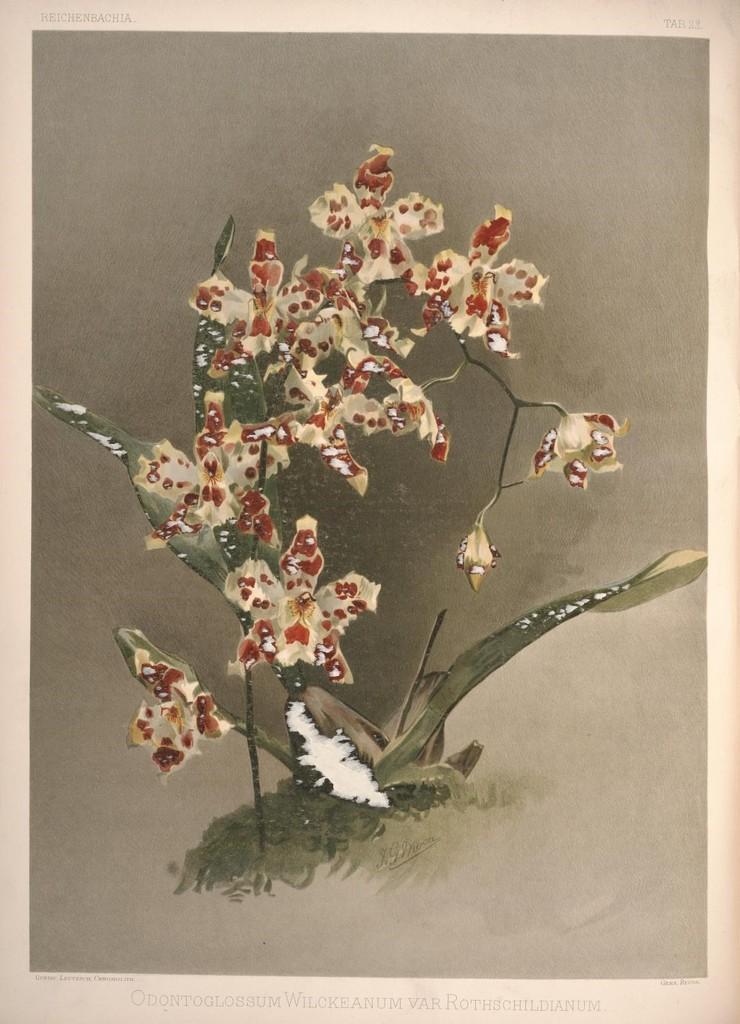Describe this image in one or two sentences. This image consists of a poster with an image of a plant on it and there is a text at the bottom of the image. 